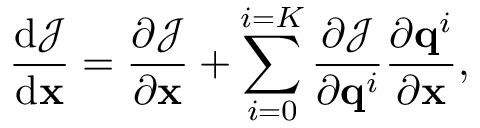Convert formula to latex. <formula><loc_0><loc_0><loc_500><loc_500>\frac { d \mathcal { J } } { d { x } } = { \frac { \partial \mathcal { J } } { \partial { x } } } + \sum _ { i = 0 } ^ { i = K } { \frac { \partial \mathcal { J } } { \partial q ^ { i } } } { \frac { \partial q ^ { i } } { \partial { x } } } ,</formula> 